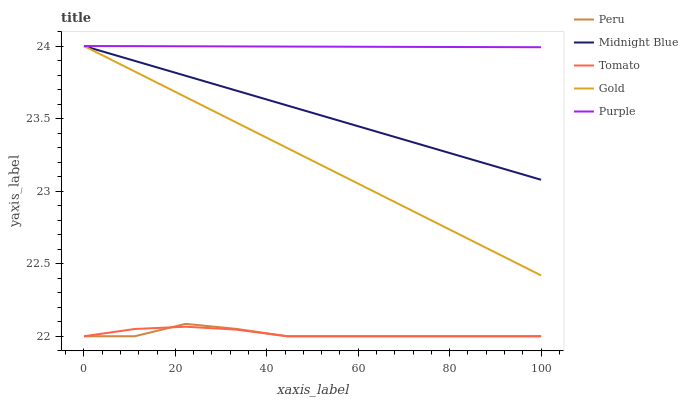Does Peru have the minimum area under the curve?
Answer yes or no. Yes. Does Purple have the maximum area under the curve?
Answer yes or no. Yes. Does Gold have the minimum area under the curve?
Answer yes or no. No. Does Gold have the maximum area under the curve?
Answer yes or no. No. Is Gold the smoothest?
Answer yes or no. Yes. Is Peru the roughest?
Answer yes or no. Yes. Is Purple the smoothest?
Answer yes or no. No. Is Purple the roughest?
Answer yes or no. No. Does Gold have the lowest value?
Answer yes or no. No. Does Midnight Blue have the highest value?
Answer yes or no. Yes. Does Peru have the highest value?
Answer yes or no. No. Is Peru less than Midnight Blue?
Answer yes or no. Yes. Is Midnight Blue greater than Peru?
Answer yes or no. Yes. Does Purple intersect Gold?
Answer yes or no. Yes. Is Purple less than Gold?
Answer yes or no. No. Is Purple greater than Gold?
Answer yes or no. No. Does Peru intersect Midnight Blue?
Answer yes or no. No. 